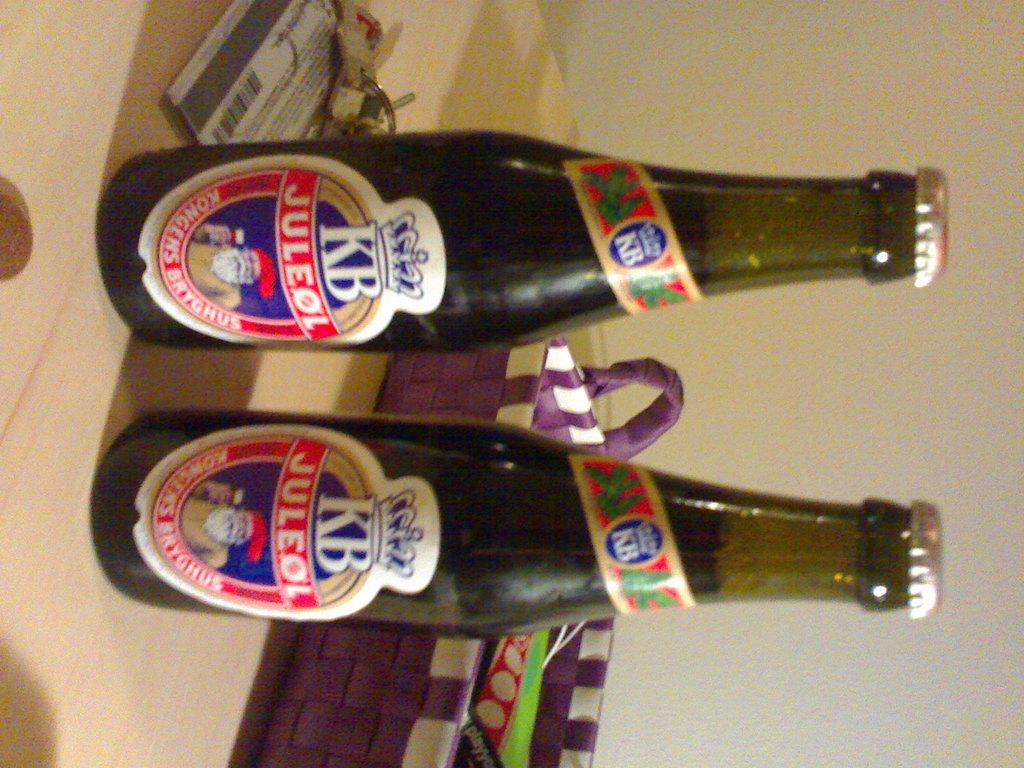What type of table is in the image? There is a wooden table in the image. What objects are on the table? There are two bottles and a basket on the table. What type of street is visible in the image? There is no street visible in the image; it only shows a wooden table with two bottles and a basket on it. 